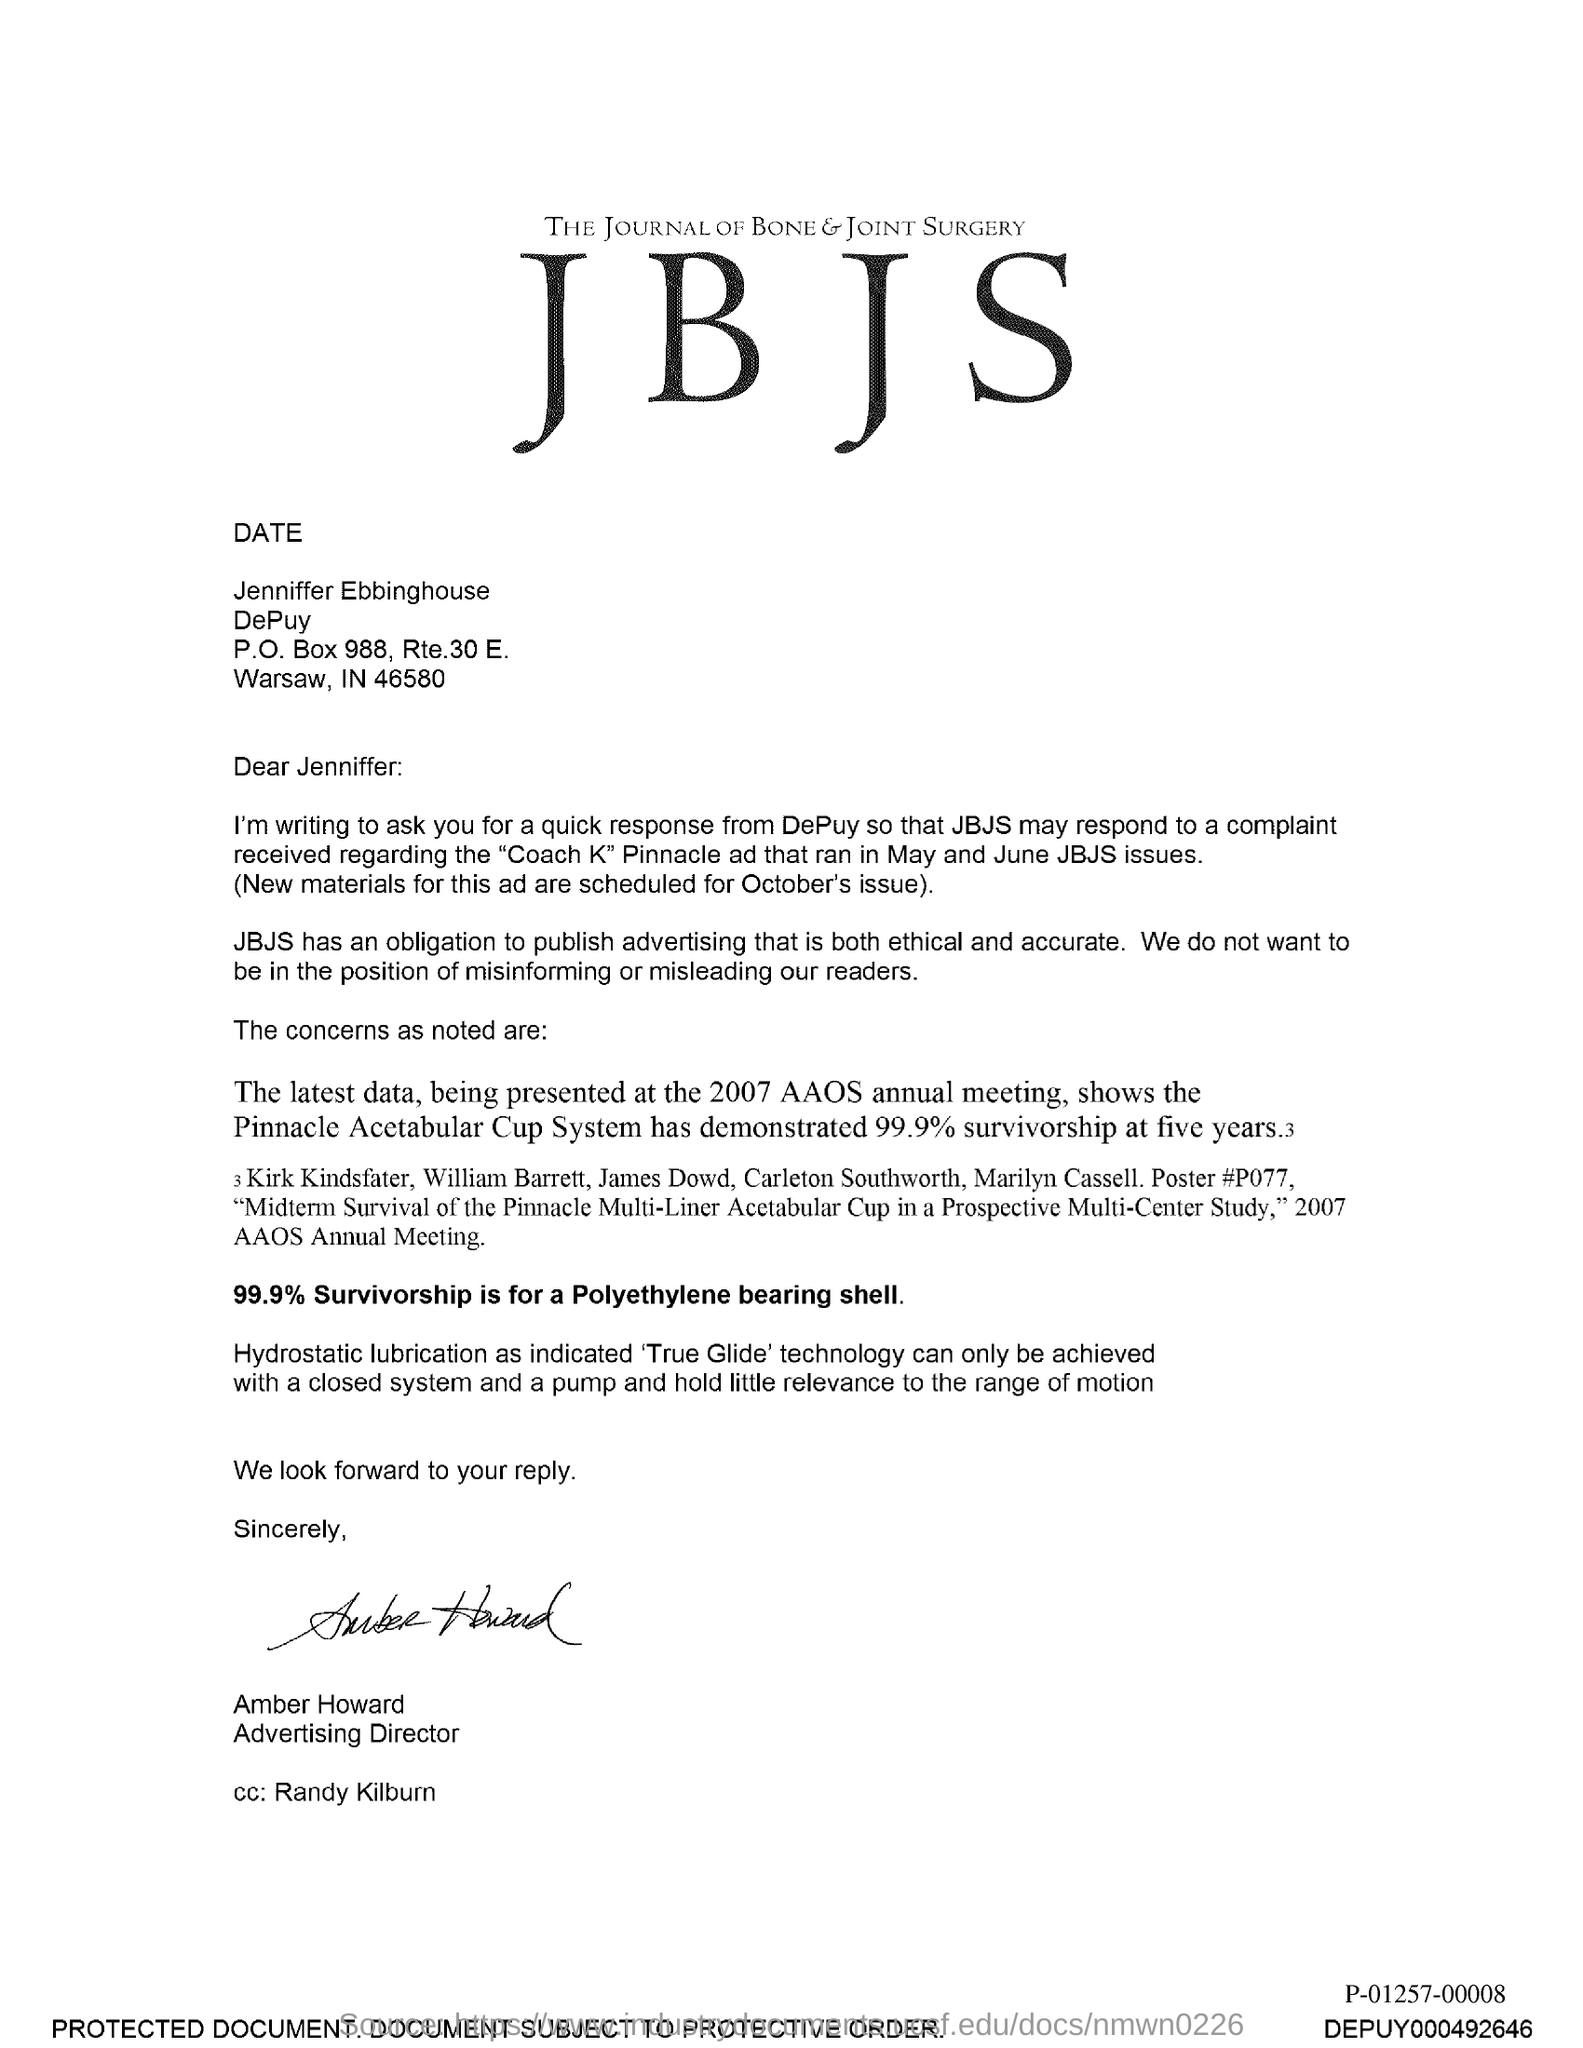Identify some key points in this picture. The fullform of JBJS is The Journal of Bone & Joint Surgery. The Journal of Bone and Joint Surgery has an obligation to publish advertising that is both ethical and accurate. The sender of this letter is Amber Howard. The survivorship rate for a polyethylene bearing shell is 99.9%. Amber Howard's designation is Advertising Director. 